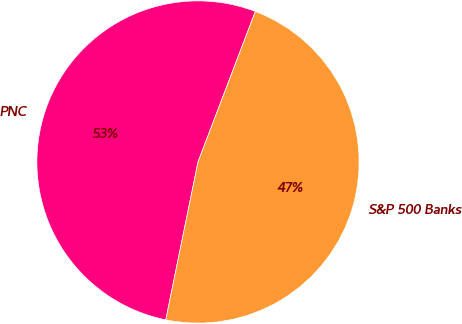Convert chart to OTSL. <chart><loc_0><loc_0><loc_500><loc_500><pie_chart><fcel>PNC<fcel>S&P 500 Banks<nl><fcel>52.59%<fcel>47.41%<nl></chart> 